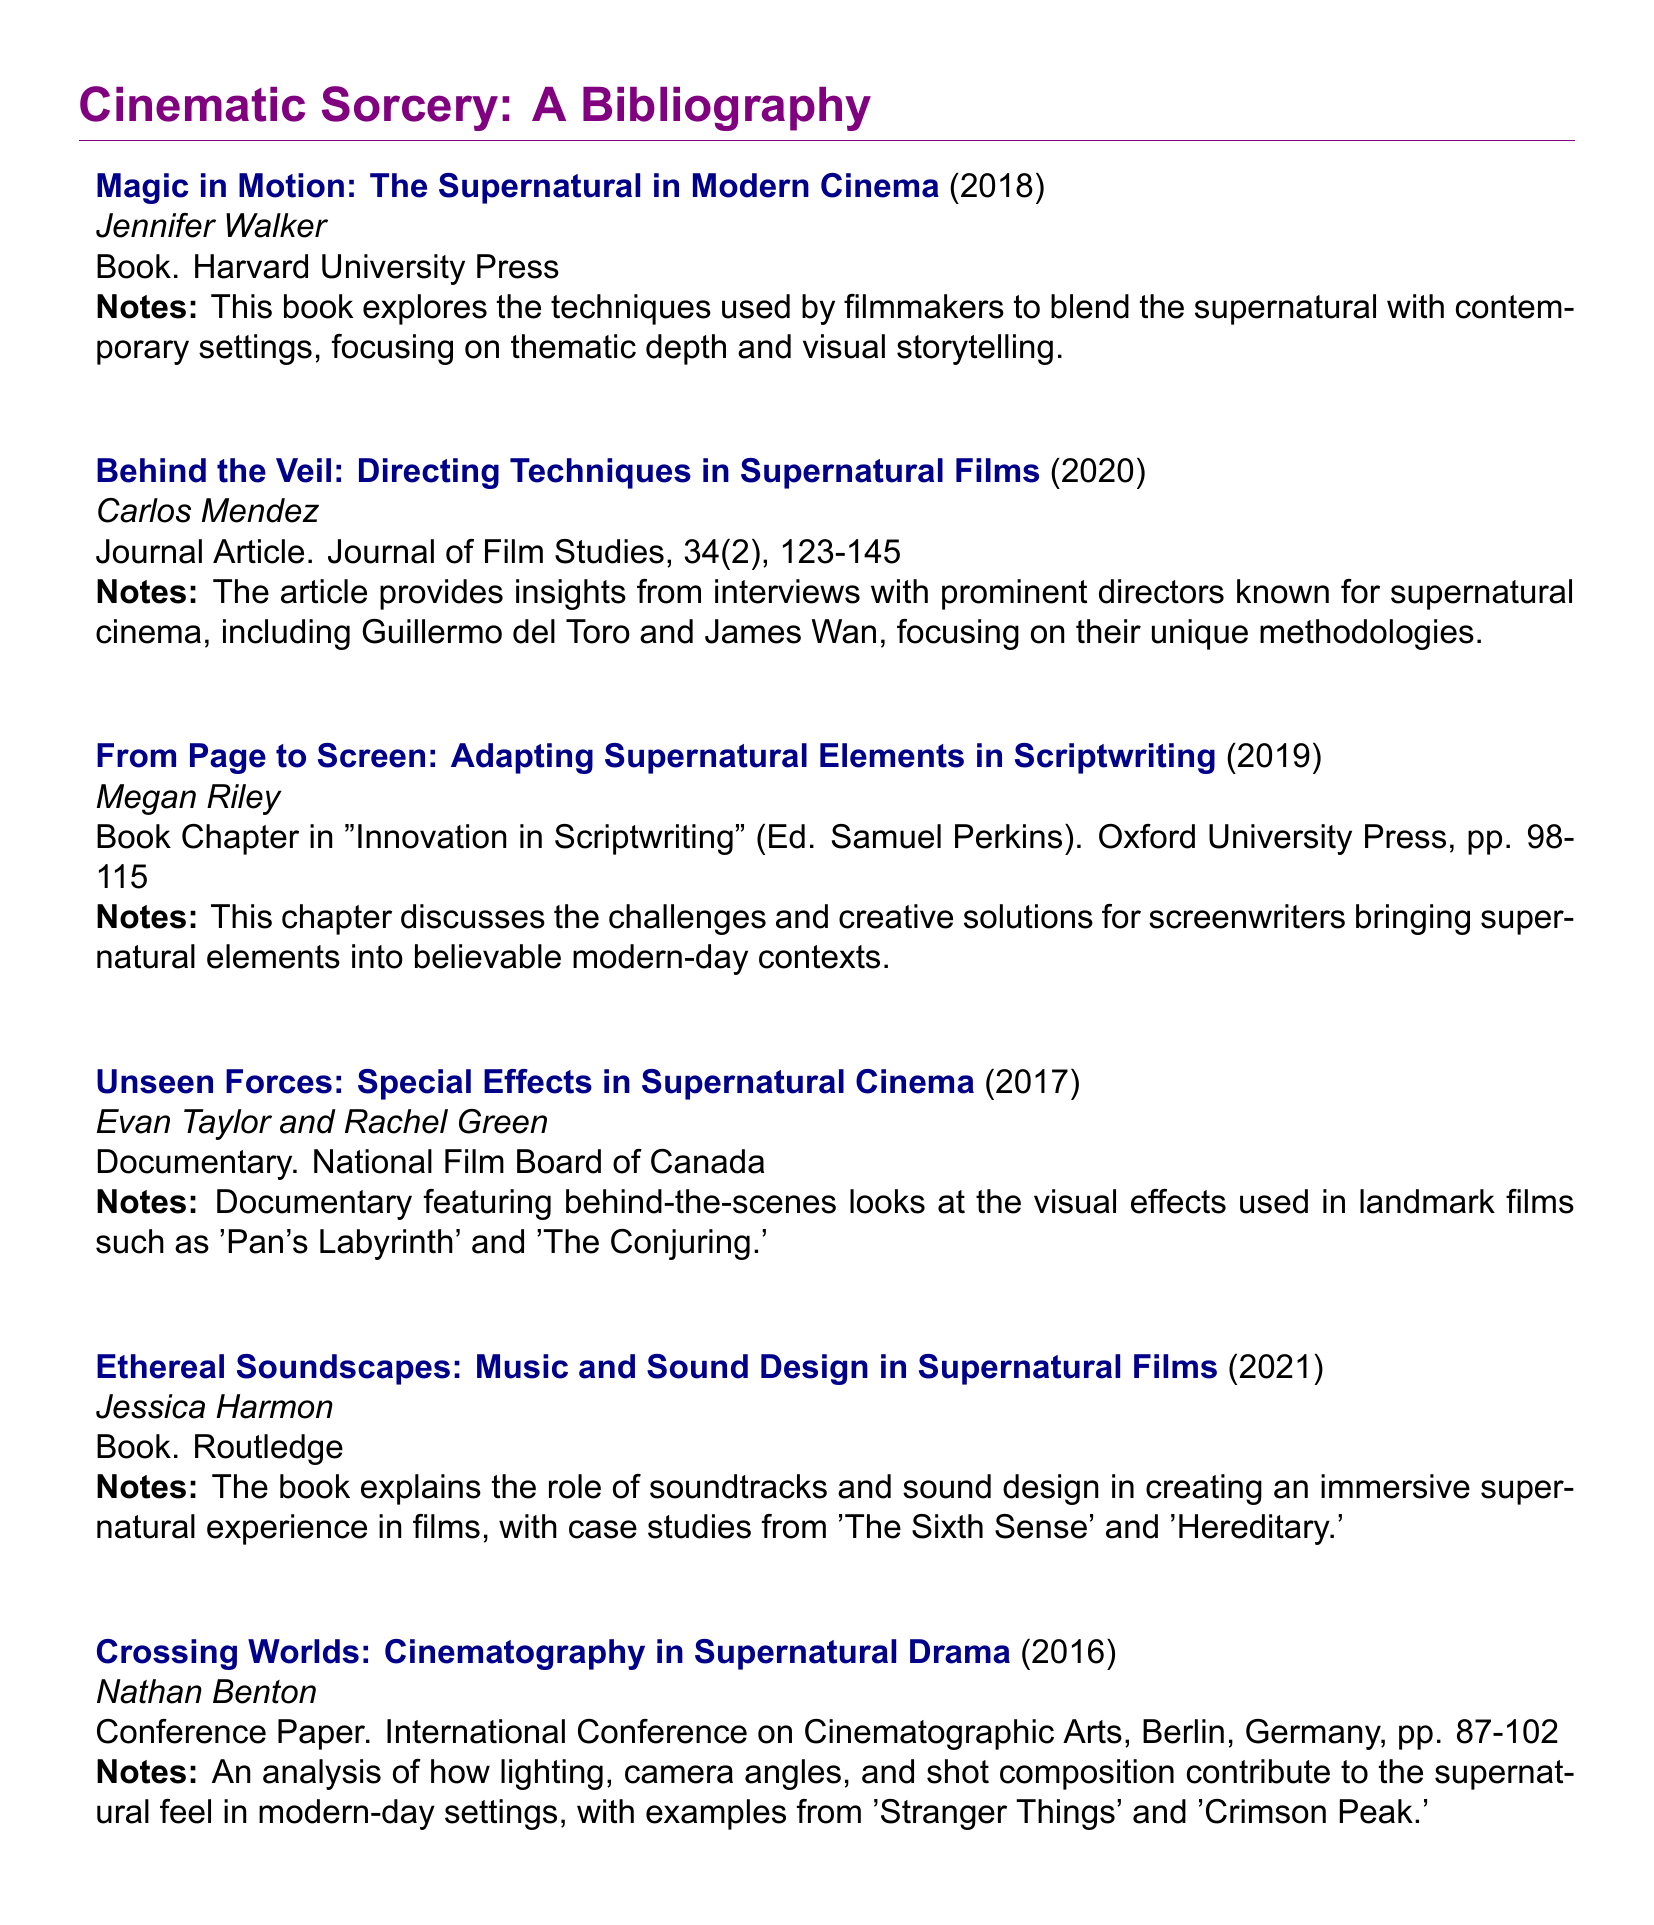What is the title of the first entry in the bibliography? The title of the first entry is the first work listed under "Cinematic Sorcery," which is "Magic in Motion: The Supernatural in Modern Cinema."
Answer: Magic in Motion: The Supernatural in Modern Cinema Who is the author of the book published in 2021? The author of the book published in 2021, "Ethereal Soundscapes: Music and Sound Design in Supernatural Films," is Jessica Harmon.
Answer: Jessica Harmon In which year was the documentary "Unseen Forces" released? The documentary "Unseen Forces: Special Effects in Supernatural Cinema" was released in 2017, as mentioned in the fourth entry.
Answer: 2017 What publication contains the article by Carlos Mendez? The article by Carlos Mendez is published in the "Journal of Film Studies," which is specified in its citation details.
Answer: Journal of Film Studies How many pages does Megan Riley's book chapter span? Megan Riley's book chapter, "From Page to Screen," spans pages 98 to 115, which indicates it covers a total of 18 pages.
Answer: 18 pages Which film is cited as an example in Nathan Benton's conference paper? Nathan Benton's conference paper, "Crossing Worlds," cites "Stranger Things" as one of the examples related to cinematography in supernatural drama.
Answer: Stranger Things Who is the editor of the book "Innovation in Scriptwriting"? The editor of the book "Innovation in Scriptwriting," in which Megan Riley's chapter appears, is Samuel Perkins.
Answer: Samuel Perkins What is the main focus of the book by Jennifer Walker? The main focus of Jennifer Walker's book is on the techniques used by filmmakers to blend supernatural elements with contemporary settings.
Answer: Techniques used by filmmakers to blend supernatural elements with contemporary settings 